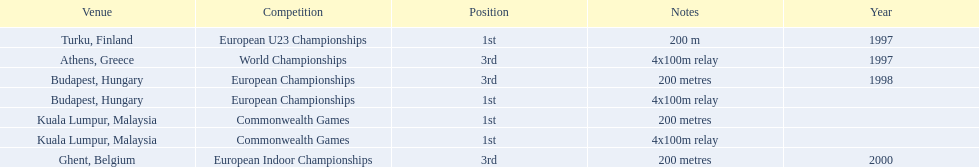Parse the table in full. {'header': ['Venue', 'Competition', 'Position', 'Notes', 'Year'], 'rows': [['Turku, Finland', 'European U23 Championships', '1st', '200 m', '1997'], ['Athens, Greece', 'World Championships', '3rd', '4x100m relay', '1997'], ['Budapest, Hungary', 'European Championships', '3rd', '200 metres', '1998'], ['Budapest, Hungary', 'European Championships', '1st', '4x100m relay', ''], ['Kuala Lumpur, Malaysia', 'Commonwealth Games', '1st', '200 metres', ''], ['Kuala Lumpur, Malaysia', 'Commonwealth Games', '1st', '4x100m relay', ''], ['Ghent, Belgium', 'European Indoor Championships', '3rd', '200 metres', '2000']]} How many times was golding in 2nd position? 0. 